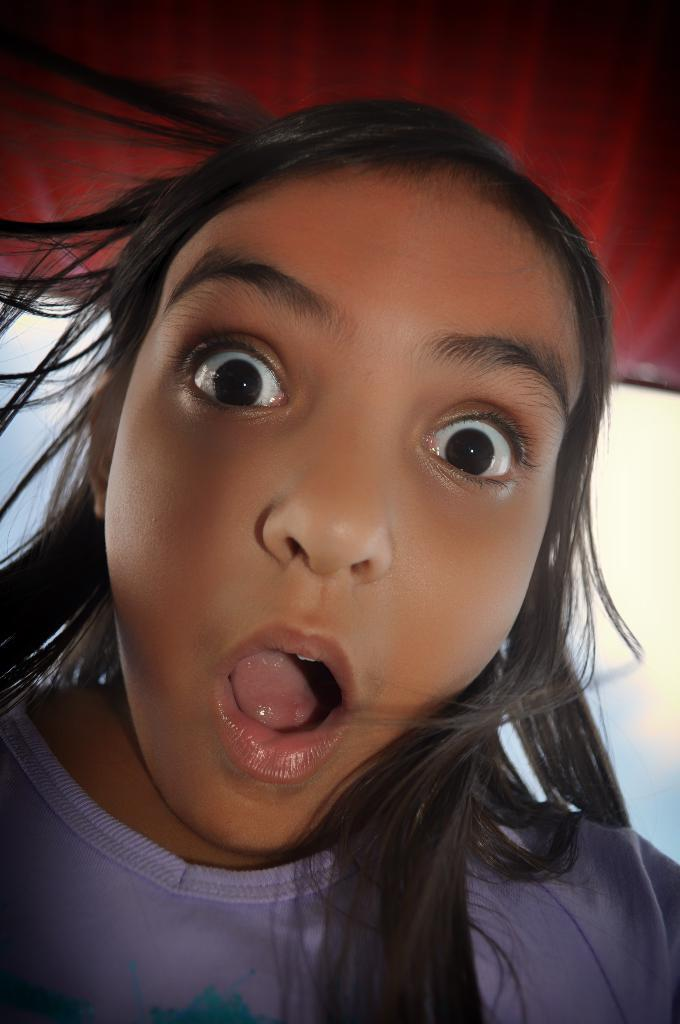Who is the main subject in the image? There is a girl in the middle of the image. How would you describe the girl's facial expression? The girl has a weird expression on her face. What can be seen in the background of the image? There is the sky with clouds in the background of the image. Can you describe the object at the top of the image? Unfortunately, the facts provided do not give enough information about the object at the top of the image. What type of yam is being used as a prop in the image? There is no yam present in the image. What sound does the thunder make in the image? There is no thunder present in the image. 